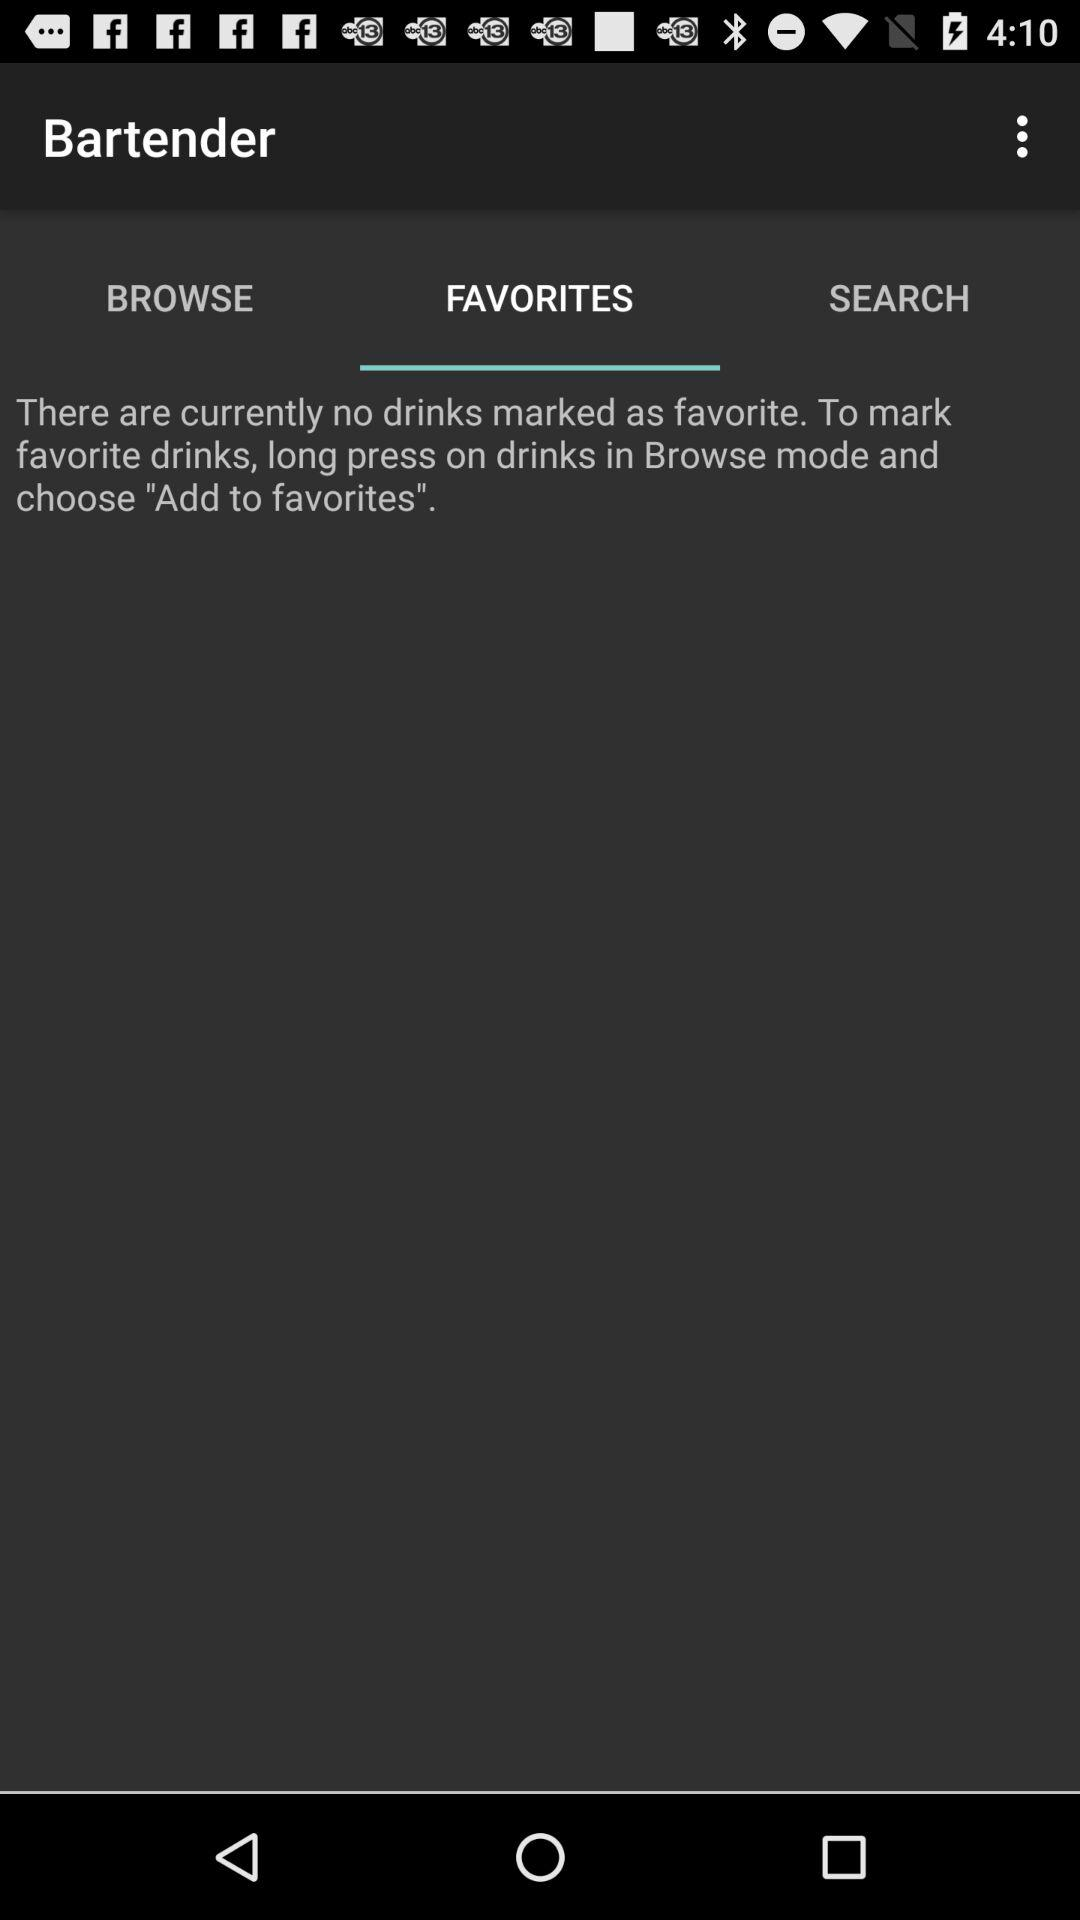Which tab is selected? The selected tab is "FAVORITES". 